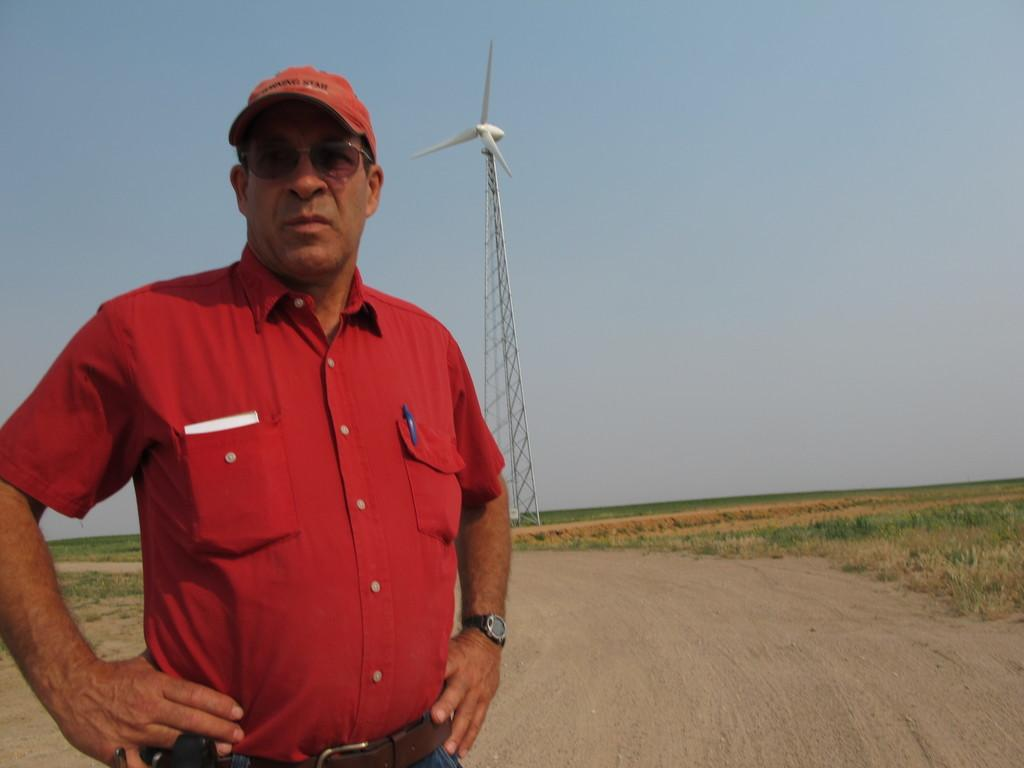What is the main subject of the image? There is a man in the image. What is the man wearing? The man is wearing a red shirt. What is the man doing in the image? The man is standing. What can be seen in the background of the image? There is a windmill in the background of the image. What is visible at the top of the image? The sky is visible at the top of the image. What is visible at the bottom of the image? The ground is visible at the bottom of the image. What type of vegetation is present in the image? There is grass in the image. How much credit does the man need to buy the windmill in the image? There is no indication in the image that the man is interested in buying the windmill, nor is there any information about the cost of the windmill or the man's financial situation. 